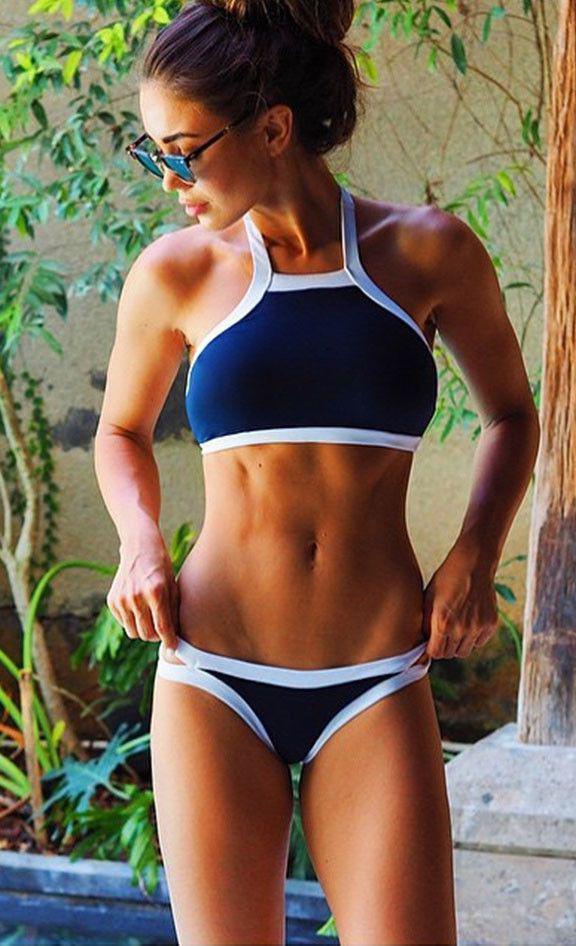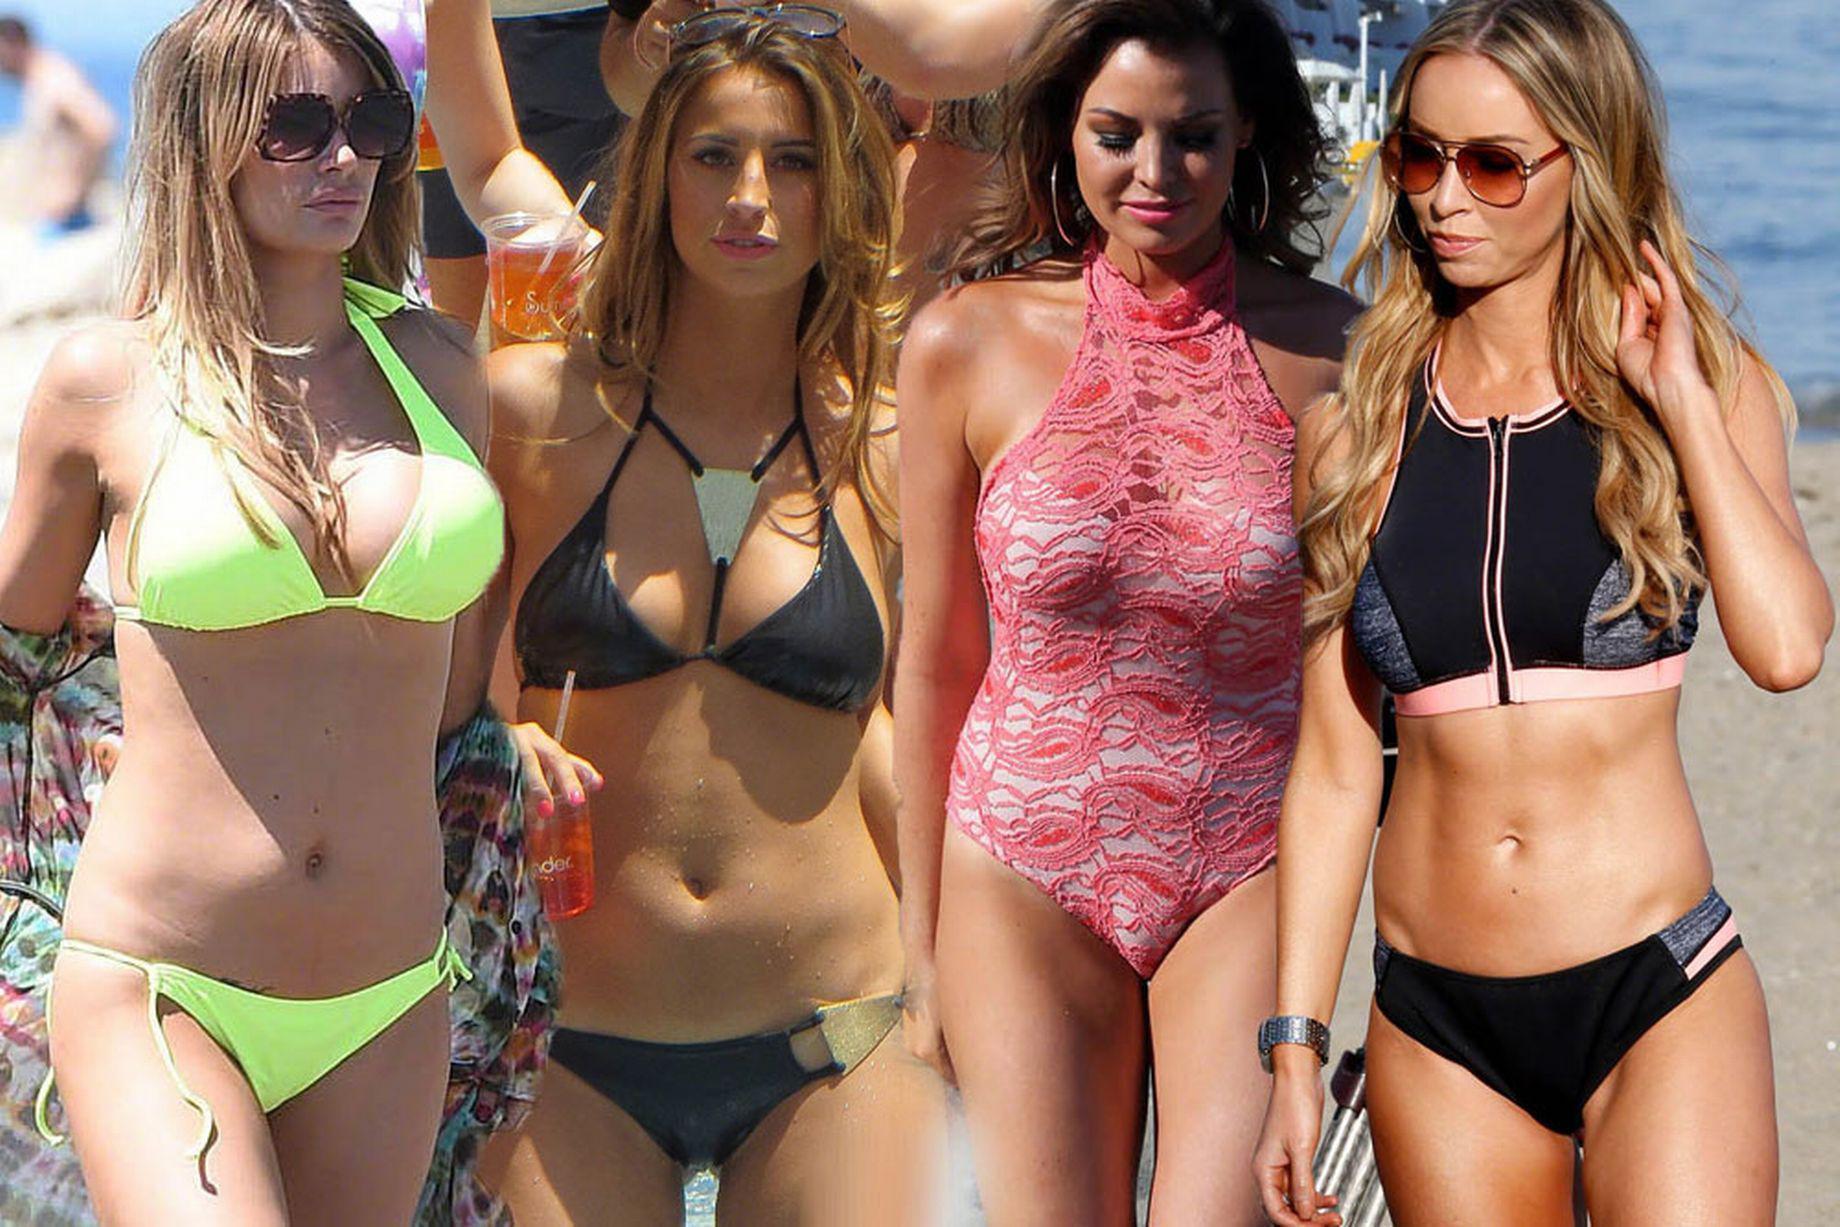The first image is the image on the left, the second image is the image on the right. Given the left and right images, does the statement "The right image shows exactly two models wearing bikinis with tops that extend over the chest and taper up to the neck." hold true? Answer yes or no. No. The first image is the image on the left, the second image is the image on the right. Considering the images on both sides, is "Both images contain the same number of women." valid? Answer yes or no. No. 